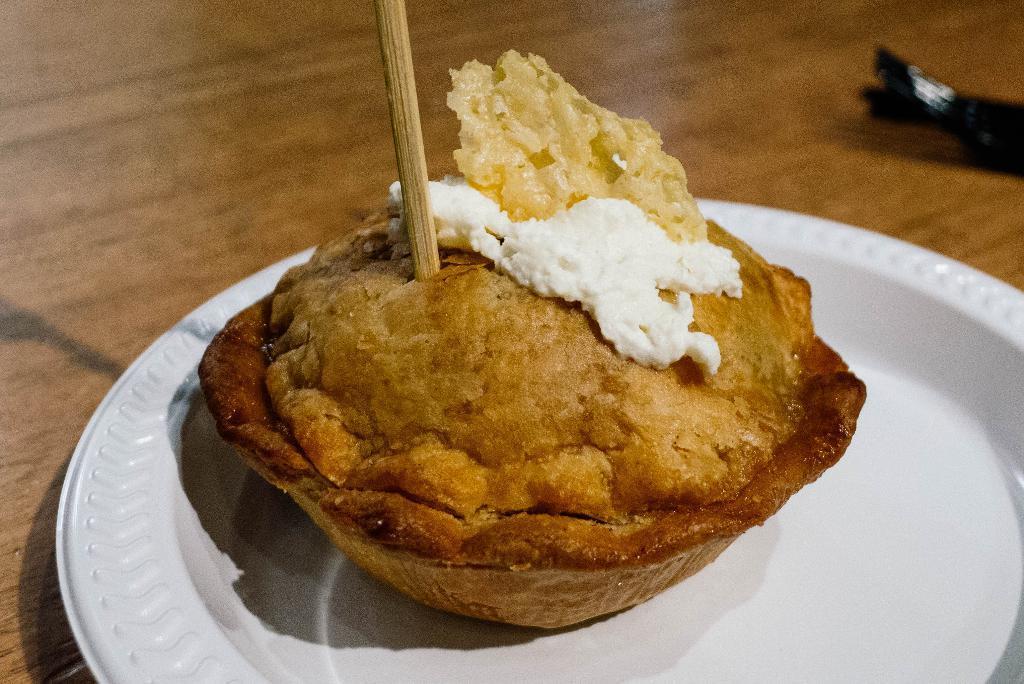How would you summarize this image in a sentence or two? In this image we can see food and stick are placed in a plate which is kept on the table. 